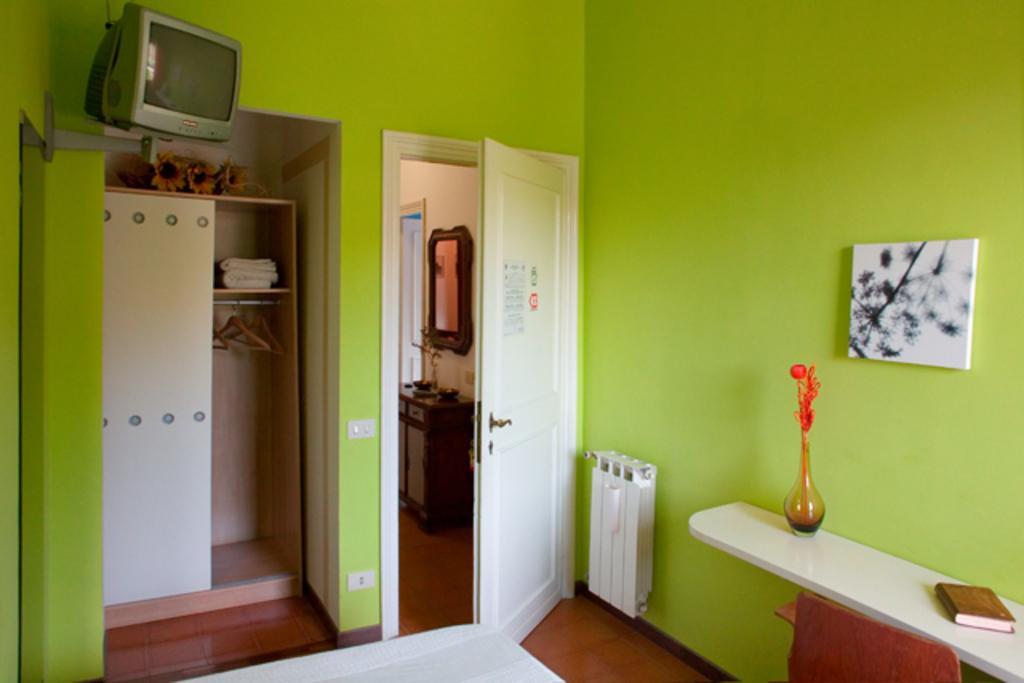Please provide a concise description of this image. In this picture I can see a television, there is a frame and a mirror attached to the wall, there is a flower vase and a book on the shelf, there is a cupboard, there are doors, there are some items in a wardrobe. 